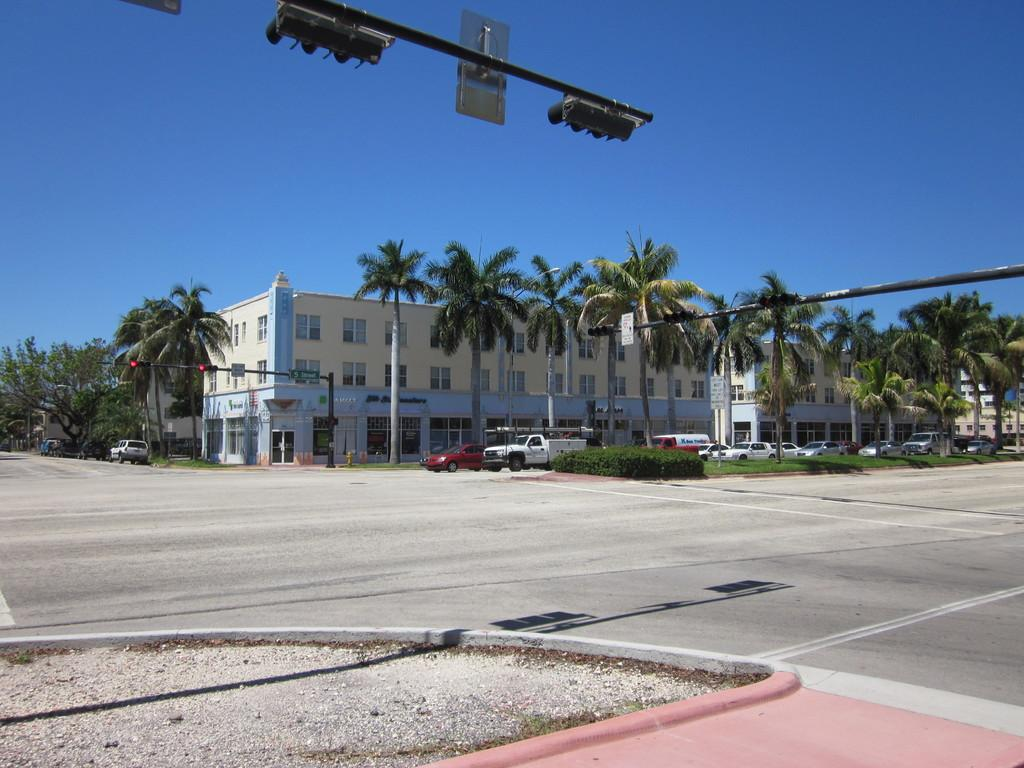What type of structures can be seen in the image? There are buildings in the image. What is happening on the road in the image? Motor vehicles are present on the road in the image. What type of vegetation is visible in the image? Trees are visible in the image. What type of infrastructure is present in the image? Traffic poles are present in the image. How do the vehicles know when to stop or go in the image? Traffic signals are visible in the image. What can be seen beneath the structures and vehicles in the image? The ground is visible in the image. What is visible above the structures and vehicles in the image? The sky is visible in the image. Where is the advertisement for the apparel company located in the image? There is no advertisement for an apparel company present in the image. What type of cave can be seen in the image? There is no cave present in the image. 